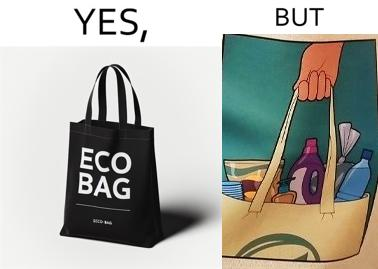Does this image contain satire or humor? Yes, this image is satirical. 